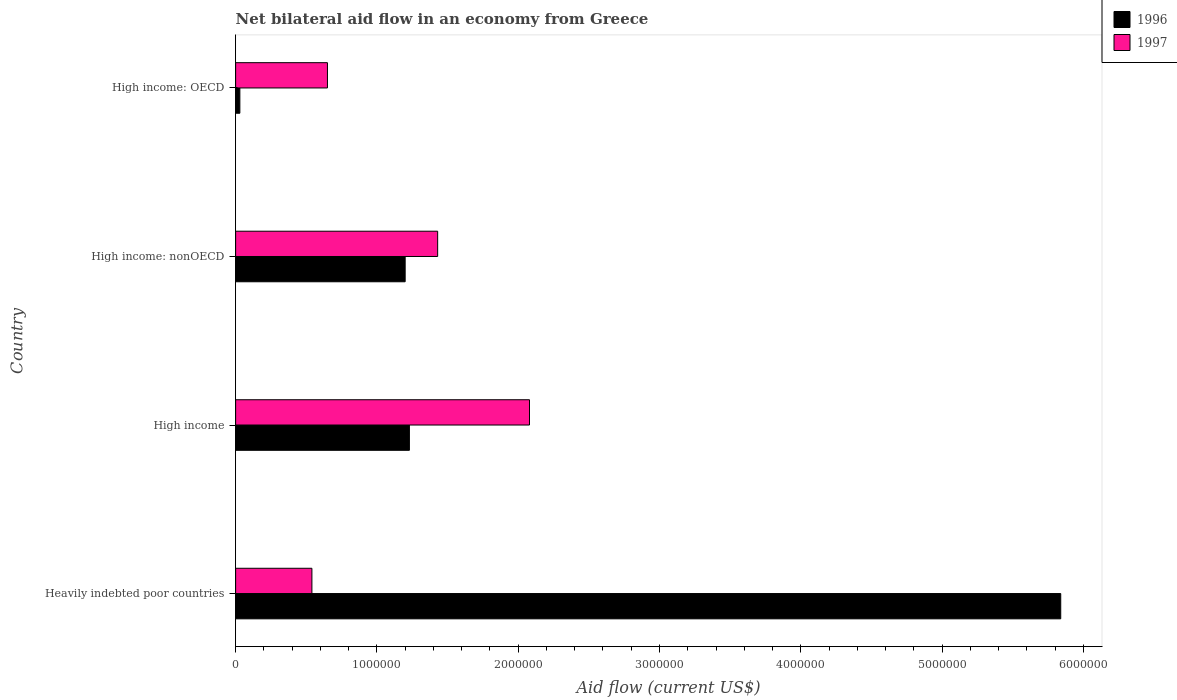Are the number of bars per tick equal to the number of legend labels?
Ensure brevity in your answer.  Yes. How many bars are there on the 4th tick from the top?
Provide a short and direct response. 2. How many bars are there on the 1st tick from the bottom?
Provide a short and direct response. 2. What is the label of the 3rd group of bars from the top?
Provide a short and direct response. High income. What is the net bilateral aid flow in 1997 in High income: OECD?
Offer a terse response. 6.50e+05. Across all countries, what is the maximum net bilateral aid flow in 1997?
Keep it short and to the point. 2.08e+06. Across all countries, what is the minimum net bilateral aid flow in 1997?
Offer a terse response. 5.40e+05. In which country was the net bilateral aid flow in 1997 maximum?
Offer a very short reply. High income. In which country was the net bilateral aid flow in 1997 minimum?
Make the answer very short. Heavily indebted poor countries. What is the total net bilateral aid flow in 1997 in the graph?
Ensure brevity in your answer.  4.70e+06. What is the difference between the net bilateral aid flow in 1997 in High income and that in High income: nonOECD?
Offer a very short reply. 6.50e+05. What is the difference between the net bilateral aid flow in 1997 in High income and the net bilateral aid flow in 1996 in High income: OECD?
Provide a succinct answer. 2.05e+06. What is the average net bilateral aid flow in 1997 per country?
Your answer should be very brief. 1.18e+06. What is the difference between the net bilateral aid flow in 1996 and net bilateral aid flow in 1997 in High income?
Ensure brevity in your answer.  -8.50e+05. In how many countries, is the net bilateral aid flow in 1997 greater than 4200000 US$?
Your answer should be compact. 0. What is the ratio of the net bilateral aid flow in 1996 in Heavily indebted poor countries to that in High income: nonOECD?
Your response must be concise. 4.87. What is the difference between the highest and the second highest net bilateral aid flow in 1997?
Give a very brief answer. 6.50e+05. What is the difference between the highest and the lowest net bilateral aid flow in 1996?
Your answer should be very brief. 5.81e+06. Is the sum of the net bilateral aid flow in 1996 in High income and High income: OECD greater than the maximum net bilateral aid flow in 1997 across all countries?
Ensure brevity in your answer.  No. What does the 2nd bar from the top in Heavily indebted poor countries represents?
Your response must be concise. 1996. How many bars are there?
Provide a short and direct response. 8. How many legend labels are there?
Ensure brevity in your answer.  2. What is the title of the graph?
Give a very brief answer. Net bilateral aid flow in an economy from Greece. What is the label or title of the X-axis?
Provide a short and direct response. Aid flow (current US$). What is the label or title of the Y-axis?
Provide a short and direct response. Country. What is the Aid flow (current US$) in 1996 in Heavily indebted poor countries?
Make the answer very short. 5.84e+06. What is the Aid flow (current US$) in 1997 in Heavily indebted poor countries?
Offer a very short reply. 5.40e+05. What is the Aid flow (current US$) of 1996 in High income?
Your response must be concise. 1.23e+06. What is the Aid flow (current US$) in 1997 in High income?
Offer a very short reply. 2.08e+06. What is the Aid flow (current US$) of 1996 in High income: nonOECD?
Make the answer very short. 1.20e+06. What is the Aid flow (current US$) of 1997 in High income: nonOECD?
Make the answer very short. 1.43e+06. What is the Aid flow (current US$) of 1997 in High income: OECD?
Your answer should be very brief. 6.50e+05. Across all countries, what is the maximum Aid flow (current US$) of 1996?
Ensure brevity in your answer.  5.84e+06. Across all countries, what is the maximum Aid flow (current US$) in 1997?
Make the answer very short. 2.08e+06. Across all countries, what is the minimum Aid flow (current US$) of 1996?
Your response must be concise. 3.00e+04. Across all countries, what is the minimum Aid flow (current US$) of 1997?
Make the answer very short. 5.40e+05. What is the total Aid flow (current US$) of 1996 in the graph?
Your answer should be compact. 8.30e+06. What is the total Aid flow (current US$) of 1997 in the graph?
Your answer should be very brief. 4.70e+06. What is the difference between the Aid flow (current US$) in 1996 in Heavily indebted poor countries and that in High income?
Provide a succinct answer. 4.61e+06. What is the difference between the Aid flow (current US$) in 1997 in Heavily indebted poor countries and that in High income?
Offer a very short reply. -1.54e+06. What is the difference between the Aid flow (current US$) of 1996 in Heavily indebted poor countries and that in High income: nonOECD?
Your answer should be very brief. 4.64e+06. What is the difference between the Aid flow (current US$) in 1997 in Heavily indebted poor countries and that in High income: nonOECD?
Offer a very short reply. -8.90e+05. What is the difference between the Aid flow (current US$) in 1996 in Heavily indebted poor countries and that in High income: OECD?
Your answer should be very brief. 5.81e+06. What is the difference between the Aid flow (current US$) in 1997 in Heavily indebted poor countries and that in High income: OECD?
Offer a terse response. -1.10e+05. What is the difference between the Aid flow (current US$) of 1996 in High income and that in High income: nonOECD?
Keep it short and to the point. 3.00e+04. What is the difference between the Aid flow (current US$) of 1997 in High income and that in High income: nonOECD?
Your answer should be very brief. 6.50e+05. What is the difference between the Aid flow (current US$) in 1996 in High income and that in High income: OECD?
Offer a terse response. 1.20e+06. What is the difference between the Aid flow (current US$) in 1997 in High income and that in High income: OECD?
Give a very brief answer. 1.43e+06. What is the difference between the Aid flow (current US$) in 1996 in High income: nonOECD and that in High income: OECD?
Provide a succinct answer. 1.17e+06. What is the difference between the Aid flow (current US$) in 1997 in High income: nonOECD and that in High income: OECD?
Give a very brief answer. 7.80e+05. What is the difference between the Aid flow (current US$) in 1996 in Heavily indebted poor countries and the Aid flow (current US$) in 1997 in High income?
Offer a very short reply. 3.76e+06. What is the difference between the Aid flow (current US$) in 1996 in Heavily indebted poor countries and the Aid flow (current US$) in 1997 in High income: nonOECD?
Keep it short and to the point. 4.41e+06. What is the difference between the Aid flow (current US$) in 1996 in Heavily indebted poor countries and the Aid flow (current US$) in 1997 in High income: OECD?
Keep it short and to the point. 5.19e+06. What is the difference between the Aid flow (current US$) in 1996 in High income and the Aid flow (current US$) in 1997 in High income: OECD?
Provide a succinct answer. 5.80e+05. What is the difference between the Aid flow (current US$) in 1996 in High income: nonOECD and the Aid flow (current US$) in 1997 in High income: OECD?
Provide a short and direct response. 5.50e+05. What is the average Aid flow (current US$) in 1996 per country?
Ensure brevity in your answer.  2.08e+06. What is the average Aid flow (current US$) in 1997 per country?
Keep it short and to the point. 1.18e+06. What is the difference between the Aid flow (current US$) of 1996 and Aid flow (current US$) of 1997 in Heavily indebted poor countries?
Give a very brief answer. 5.30e+06. What is the difference between the Aid flow (current US$) of 1996 and Aid flow (current US$) of 1997 in High income?
Give a very brief answer. -8.50e+05. What is the difference between the Aid flow (current US$) in 1996 and Aid flow (current US$) in 1997 in High income: OECD?
Give a very brief answer. -6.20e+05. What is the ratio of the Aid flow (current US$) of 1996 in Heavily indebted poor countries to that in High income?
Ensure brevity in your answer.  4.75. What is the ratio of the Aid flow (current US$) of 1997 in Heavily indebted poor countries to that in High income?
Provide a short and direct response. 0.26. What is the ratio of the Aid flow (current US$) of 1996 in Heavily indebted poor countries to that in High income: nonOECD?
Ensure brevity in your answer.  4.87. What is the ratio of the Aid flow (current US$) of 1997 in Heavily indebted poor countries to that in High income: nonOECD?
Your answer should be very brief. 0.38. What is the ratio of the Aid flow (current US$) of 1996 in Heavily indebted poor countries to that in High income: OECD?
Keep it short and to the point. 194.67. What is the ratio of the Aid flow (current US$) of 1997 in Heavily indebted poor countries to that in High income: OECD?
Ensure brevity in your answer.  0.83. What is the ratio of the Aid flow (current US$) in 1997 in High income to that in High income: nonOECD?
Offer a terse response. 1.45. What is the ratio of the Aid flow (current US$) in 1996 in High income: nonOECD to that in High income: OECD?
Provide a short and direct response. 40. What is the ratio of the Aid flow (current US$) in 1997 in High income: nonOECD to that in High income: OECD?
Offer a very short reply. 2.2. What is the difference between the highest and the second highest Aid flow (current US$) in 1996?
Offer a terse response. 4.61e+06. What is the difference between the highest and the second highest Aid flow (current US$) of 1997?
Your answer should be compact. 6.50e+05. What is the difference between the highest and the lowest Aid flow (current US$) in 1996?
Make the answer very short. 5.81e+06. What is the difference between the highest and the lowest Aid flow (current US$) in 1997?
Offer a very short reply. 1.54e+06. 